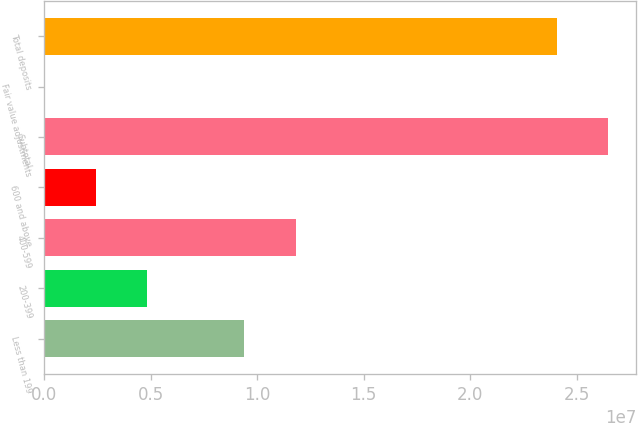Convert chart to OTSL. <chart><loc_0><loc_0><loc_500><loc_500><bar_chart><fcel>Less than 199<fcel>200-399<fcel>400-599<fcel>600 and above<fcel>Subtotal<fcel>Fair value adjustments<fcel>Total deposits<nl><fcel>9.40123e+06<fcel>4.818e+06<fcel>1.18083e+07<fcel>2.4109e+06<fcel>2.64781e+07<fcel>3800<fcel>2.4071e+07<nl></chart> 